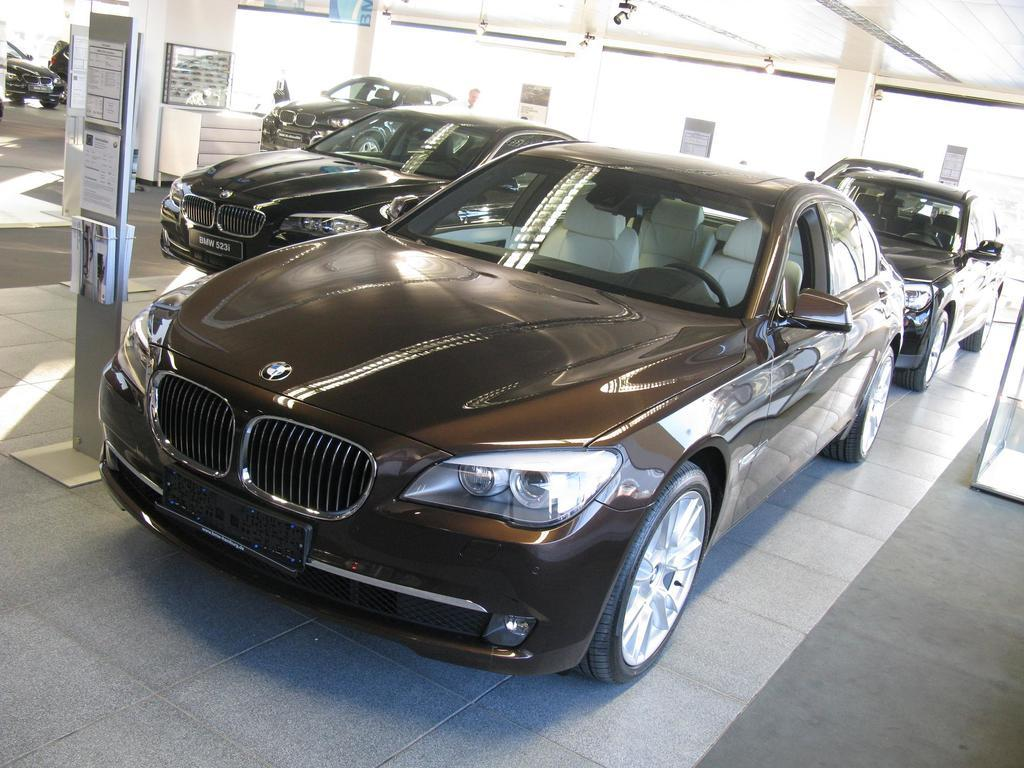What type of vehicles can be seen in the image? There are cars in the image. What architectural features are present in the image? There are pillars in the image. What is on the floor in the image? There are objects on the floor in the image. Where is the camera located in the image? The camera is visible in the background on the ceiling. What is the opinion of the brain about the drain in the image? There is no brain or drain present in the image, so it is not possible to determine an opinion. 